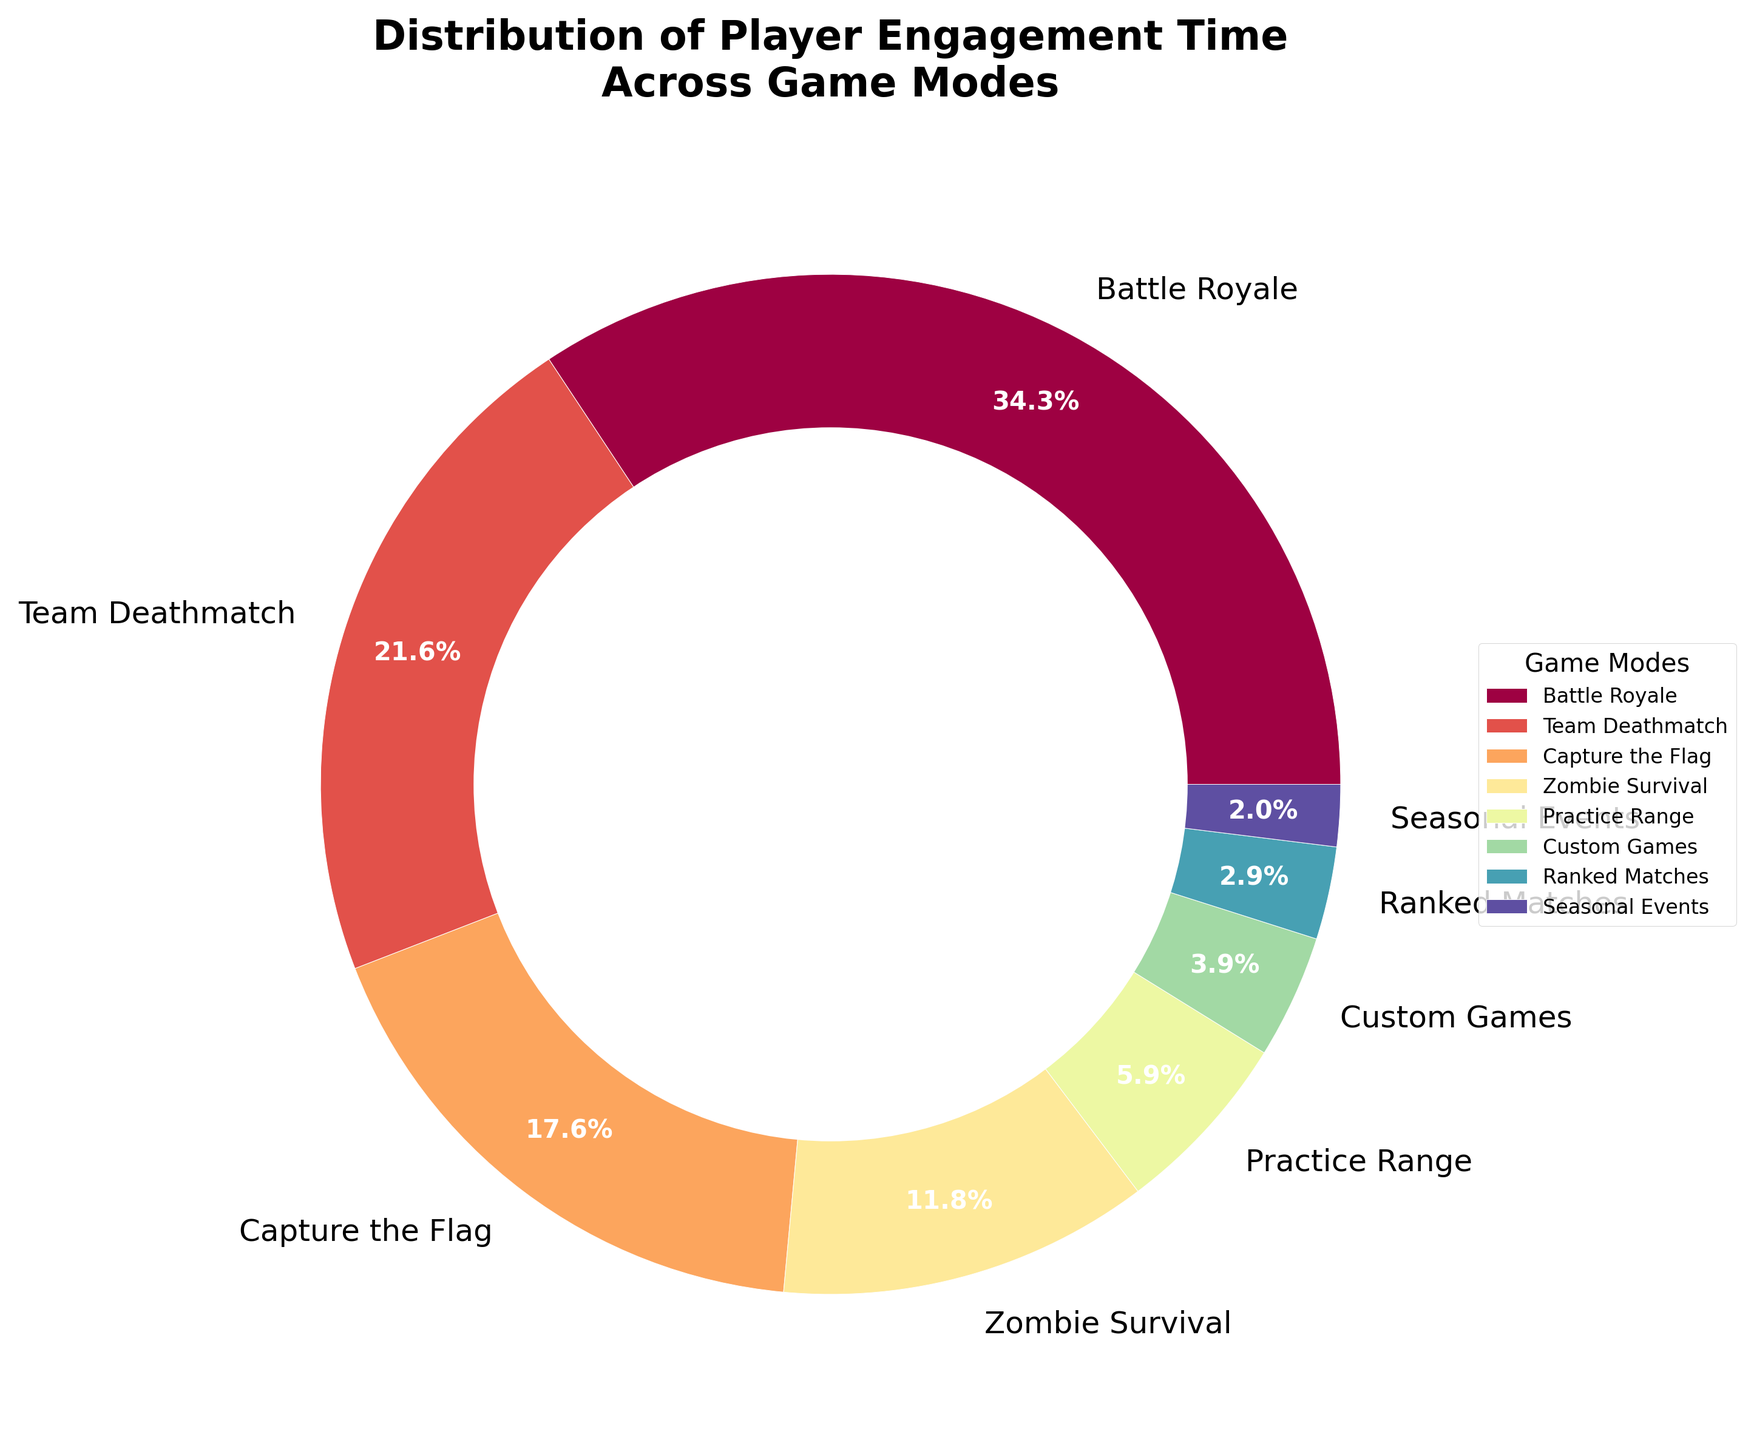What's the most popular game mode based on player engagement time? The most popular game mode will have the largest percentage in the pie chart. By looking at the figure, "Battle Royale" has the largest segment, which is 35%.
Answer: Battle Royale Which game mode has the least engagement time? The least engaging game mode will have the smallest segment in the pie chart. The figure shows that "Seasonal Events" accounts for only 2%.
Answer: Seasonal Events How much more engagement time does "Team Deathmatch" have compared to "Ranked Matches"? Find the engagement percentages for both modes: "Team Deathmatch" has 22% and "Ranked Matches" has 3%. Subtract 3% from 22% to get the difference.
Answer: 19% If you combine the engagement times for "Custom Games" and "Practice Range," what is the total percentage? Look at the pie chart to find the percentages: "Custom Games" has 4% and "Practice Range" has 6%. Adding these together gives 4% + 6% = 10%.
Answer: 10% Which game modes have an engagement time greater than 10%? Identifying the segments with more than 10% in the pie chart points to: "Battle Royale" (35%), "Team Deathmatch" (22%), "Capture the Flag" (18%), and "Zombie Survival" (12%).
Answer: Battle Royale, Team Deathmatch, Capture the Flag, Zombie Survival What percentage of players engage in either "Capture the Flag" or "Zombie Survival"? The engagement times for both are "Capture the Flag" with 18% and "Zombie Survival" with 12%. Adding these, 18% + 12% = 30%.
Answer: 30% Compare the engagement times between “Battle Royale” and the total for all game modes combined except “Battle Royale”. "Battle Royale" has 35%. The total for other game modes would be the sum of their percentages: 22% + 18% + 12% + 6% + 4% + 3% + 2% = 67%. Thus, 35% vs 67%.
Answer: Battle Royale: 35%, Others: 67% Which game mode has the third highest player engagement? By looking at the segments in descending order of engagement: 1) Battle Royale: 35%, 2) Team Deathmatch: 22%, 3) Capture the Flag: 18%. Therefore, the third highest is "Capture the Flag”.
Answer: Capture the Flag How much lower is the player engagement for "Seasonal Events" compared to "Zombie Survival"? “Seasonal Events” has 2% engagement and “Zombie Survival” has 12%, so the difference is 12% - 2% = 10%.
Answer: 10% What is the visual color relationship between "Practice Range" and “Custom Games” in the pie chart? Both game modes are represented by segments in the pie chart. "Practice Range" comes before "Custom Games" in order, typically assigned colors close in spectrum, but the exact visual shades are not specified. The general spectral shades would be similar but are distinguished by position in the chart.
Answer: Similar spectral shades, distinguished by position in the chart 